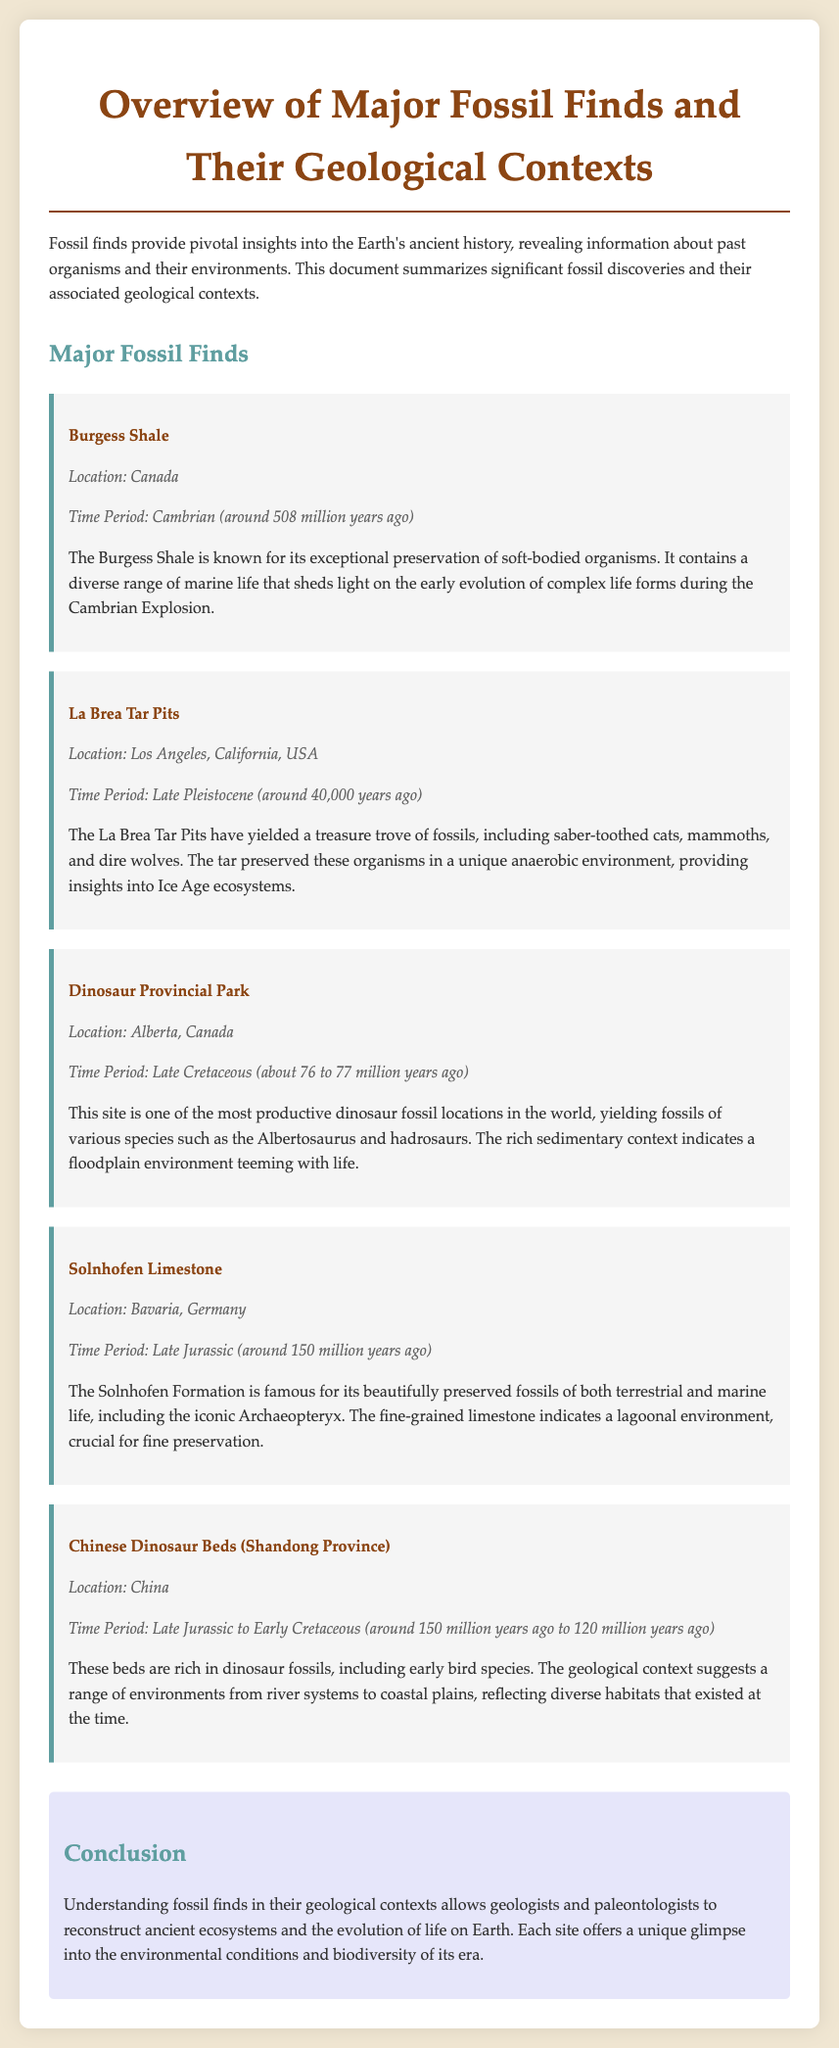What is the time period of the Burgess Shale? The time period for the Burgess Shale is specified in the document as Cambrian, around 508 million years ago.
Answer: Cambrian (around 508 million years ago) What organisms were found at the La Brea Tar Pits? The document mentions saber-toothed cats, mammoths, and dire wolves as significant finds at the La Brea Tar Pits.
Answer: Saber-toothed cats, mammoths, and dire wolves Which fossil find is known for the Archaeopteryx? The Solnhofen Limestone is highlighted in the document for its beautifully preserved fossils, including the iconic Archaeopteryx.
Answer: Solnhofen Limestone What type of environment is indicated by the Dinosaur Provincial Park? The document states that the sedimentary context of the Dinosaur Provincial Park indicates a floodplain environment.
Answer: Floodplain environment During which era did the Chinese Dinosaur Beds exist? The document describes the time period for the Chinese Dinosaur Beds as Late Jurassic to Early Cretaceous, around 150 million years ago to 120 million years ago.
Answer: Late Jurassic to Early Cretaceous Which province is home to the Chinese Dinosaur Beds? The location of the Chinese Dinosaur Beds is specified as Shandong Province in China.
Answer: Shandong Province What is the significance of understanding fossil finds in their geological contexts? The document concludes that understanding fossil finds allows reconstruction of ancient ecosystems and the evolution of life on Earth.
Answer: Reconstruction of ancient ecosystems What type of fossils does the Solnhofen Limestone preserve? The document mentions that the Solnhofen Formation preserves both terrestrial and marine life.
Answer: Terrestrial and marine life 